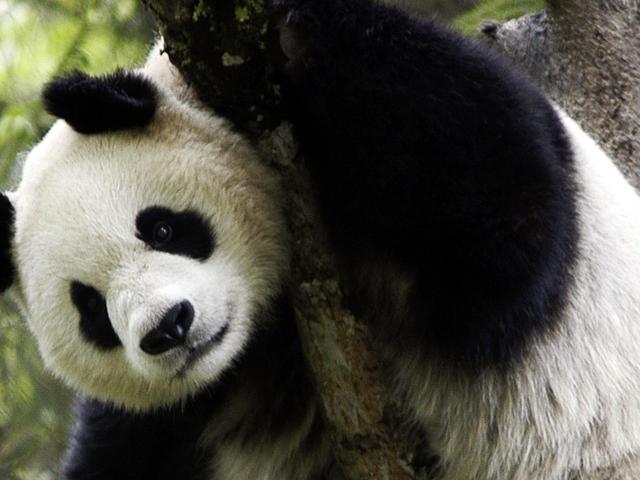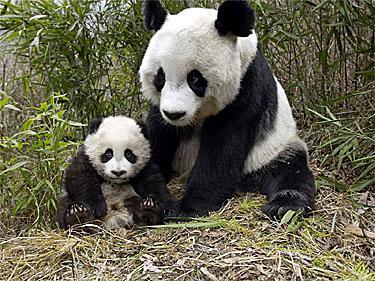The first image is the image on the left, the second image is the image on the right. Given the left and right images, does the statement "In one of the images, a panda is eating something" hold true? Answer yes or no. No. The first image is the image on the left, the second image is the image on the right. Considering the images on both sides, is "In one of the images, a panda has food in its mouth" valid? Answer yes or no. No. The first image is the image on the left, the second image is the image on the right. For the images displayed, is the sentence "A panda is eating in one of the images." factually correct? Answer yes or no. No. 